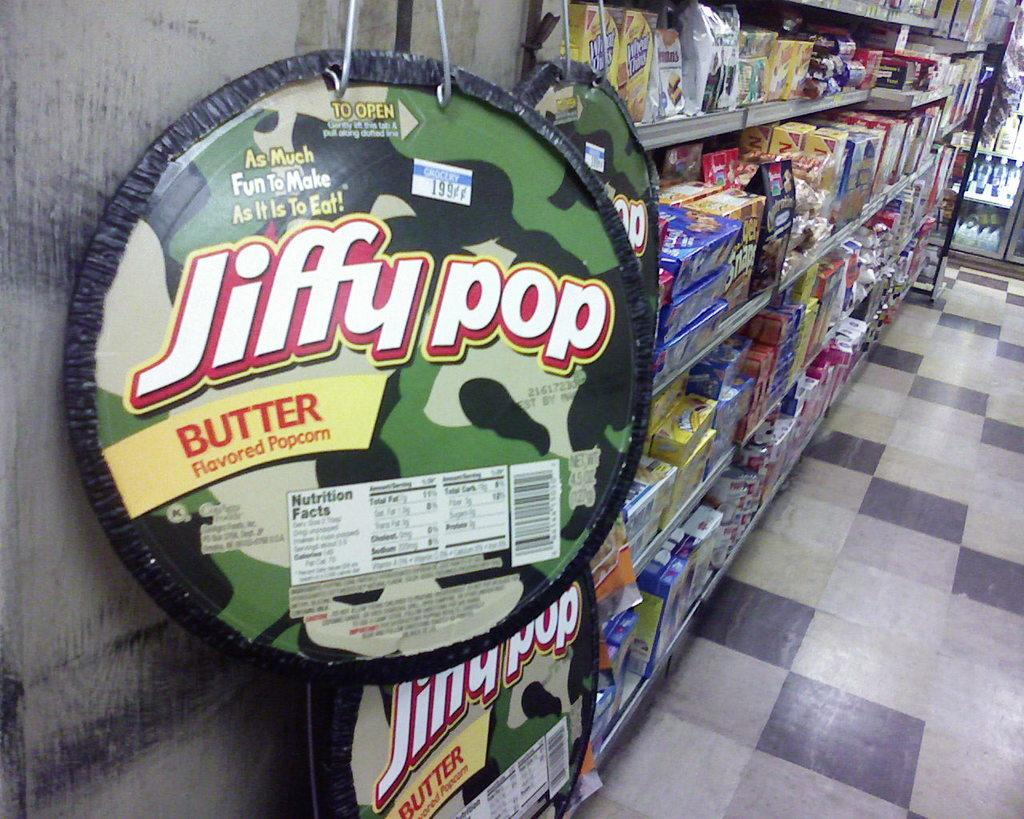<image>
Give a short and clear explanation of the subsequent image. a snack aisle in a store with jiffy pop butter popcorn on display 